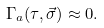Convert formula to latex. <formula><loc_0><loc_0><loc_500><loc_500>\Gamma _ { a } ( \tau , \vec { \sigma } ) \approx 0 .</formula> 